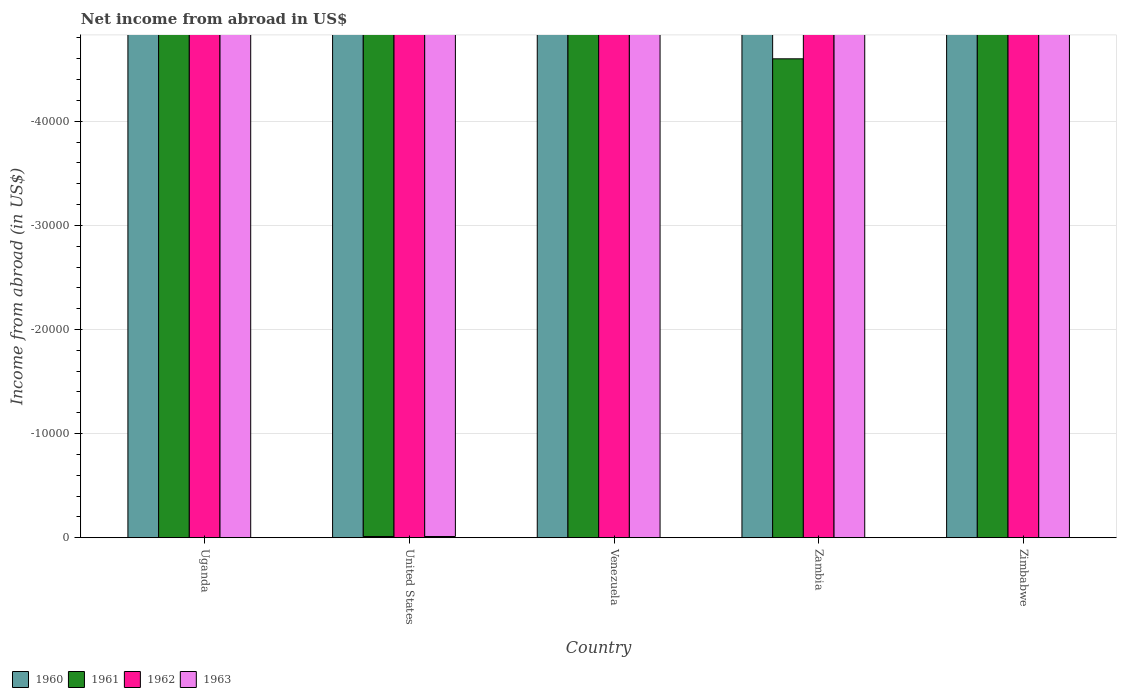How many different coloured bars are there?
Your answer should be very brief. 0. Are the number of bars per tick equal to the number of legend labels?
Provide a short and direct response. No. How many bars are there on the 1st tick from the right?
Give a very brief answer. 0. What is the label of the 2nd group of bars from the left?
Keep it short and to the point. United States. In how many cases, is the number of bars for a given country not equal to the number of legend labels?
Provide a short and direct response. 5. What is the total net income from abroad in 1962 in the graph?
Ensure brevity in your answer.  0. In how many countries, is the net income from abroad in 1961 greater than -22000 US$?
Your response must be concise. 0. In how many countries, is the net income from abroad in 1962 greater than the average net income from abroad in 1962 taken over all countries?
Make the answer very short. 0. How many bars are there?
Give a very brief answer. 0. Are all the bars in the graph horizontal?
Offer a very short reply. No. What is the difference between two consecutive major ticks on the Y-axis?
Your answer should be very brief. 10000. Are the values on the major ticks of Y-axis written in scientific E-notation?
Keep it short and to the point. No. How many legend labels are there?
Provide a short and direct response. 4. What is the title of the graph?
Keep it short and to the point. Net income from abroad in US$. What is the label or title of the X-axis?
Make the answer very short. Country. What is the label or title of the Y-axis?
Your answer should be compact. Income from abroad (in US$). What is the Income from abroad (in US$) in 1960 in Uganda?
Ensure brevity in your answer.  0. What is the Income from abroad (in US$) of 1961 in Uganda?
Keep it short and to the point. 0. What is the Income from abroad (in US$) of 1962 in Uganda?
Your answer should be compact. 0. What is the Income from abroad (in US$) in 1963 in Uganda?
Provide a succinct answer. 0. What is the Income from abroad (in US$) of 1960 in United States?
Ensure brevity in your answer.  0. What is the Income from abroad (in US$) of 1962 in United States?
Your answer should be very brief. 0. What is the Income from abroad (in US$) in 1963 in United States?
Provide a short and direct response. 0. What is the Income from abroad (in US$) in 1961 in Venezuela?
Keep it short and to the point. 0. What is the Income from abroad (in US$) in 1962 in Venezuela?
Give a very brief answer. 0. What is the Income from abroad (in US$) in 1961 in Zambia?
Provide a short and direct response. 0. What is the Income from abroad (in US$) in 1960 in Zimbabwe?
Keep it short and to the point. 0. What is the Income from abroad (in US$) in 1961 in Zimbabwe?
Offer a very short reply. 0. What is the total Income from abroad (in US$) in 1961 in the graph?
Offer a terse response. 0. What is the total Income from abroad (in US$) in 1962 in the graph?
Offer a terse response. 0. What is the average Income from abroad (in US$) in 1960 per country?
Your answer should be compact. 0. What is the average Income from abroad (in US$) in 1961 per country?
Provide a succinct answer. 0. What is the average Income from abroad (in US$) of 1962 per country?
Make the answer very short. 0. 